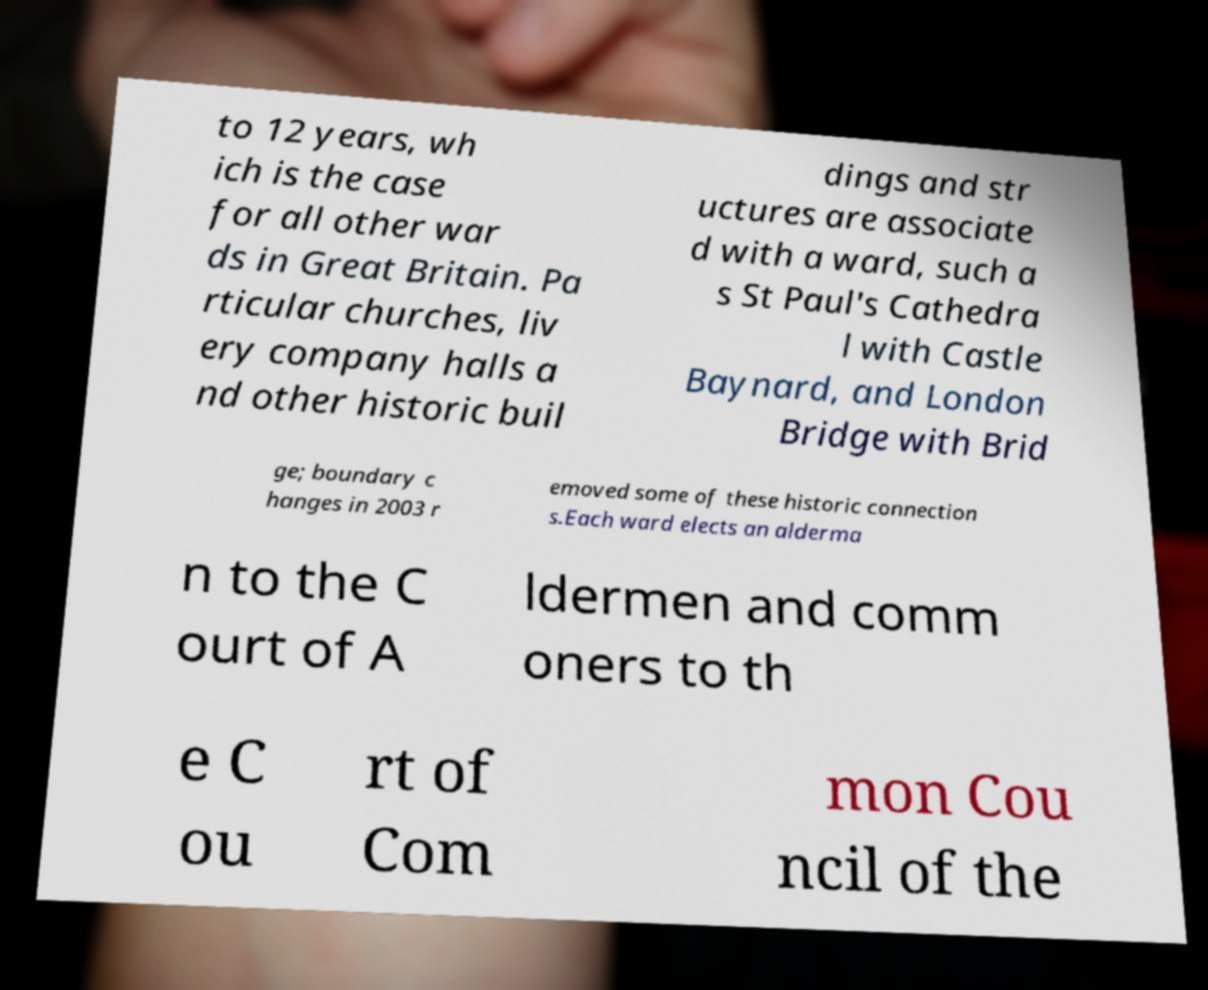I need the written content from this picture converted into text. Can you do that? to 12 years, wh ich is the case for all other war ds in Great Britain. Pa rticular churches, liv ery company halls a nd other historic buil dings and str uctures are associate d with a ward, such a s St Paul's Cathedra l with Castle Baynard, and London Bridge with Brid ge; boundary c hanges in 2003 r emoved some of these historic connection s.Each ward elects an alderma n to the C ourt of A ldermen and comm oners to th e C ou rt of Com mon Cou ncil of the 